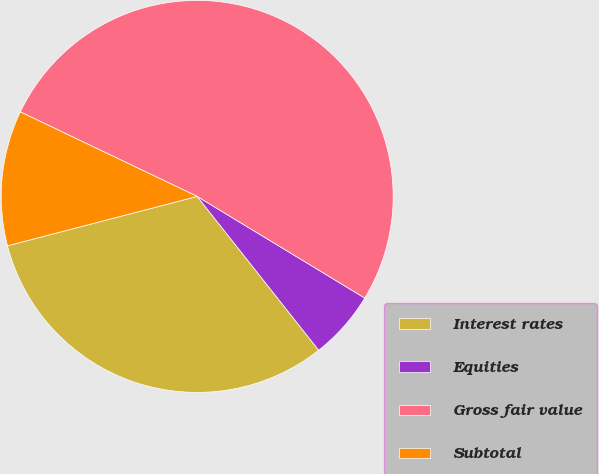<chart> <loc_0><loc_0><loc_500><loc_500><pie_chart><fcel>Interest rates<fcel>Equities<fcel>Gross fair value<fcel>Subtotal<nl><fcel>31.59%<fcel>5.68%<fcel>51.58%<fcel>11.15%<nl></chart> 